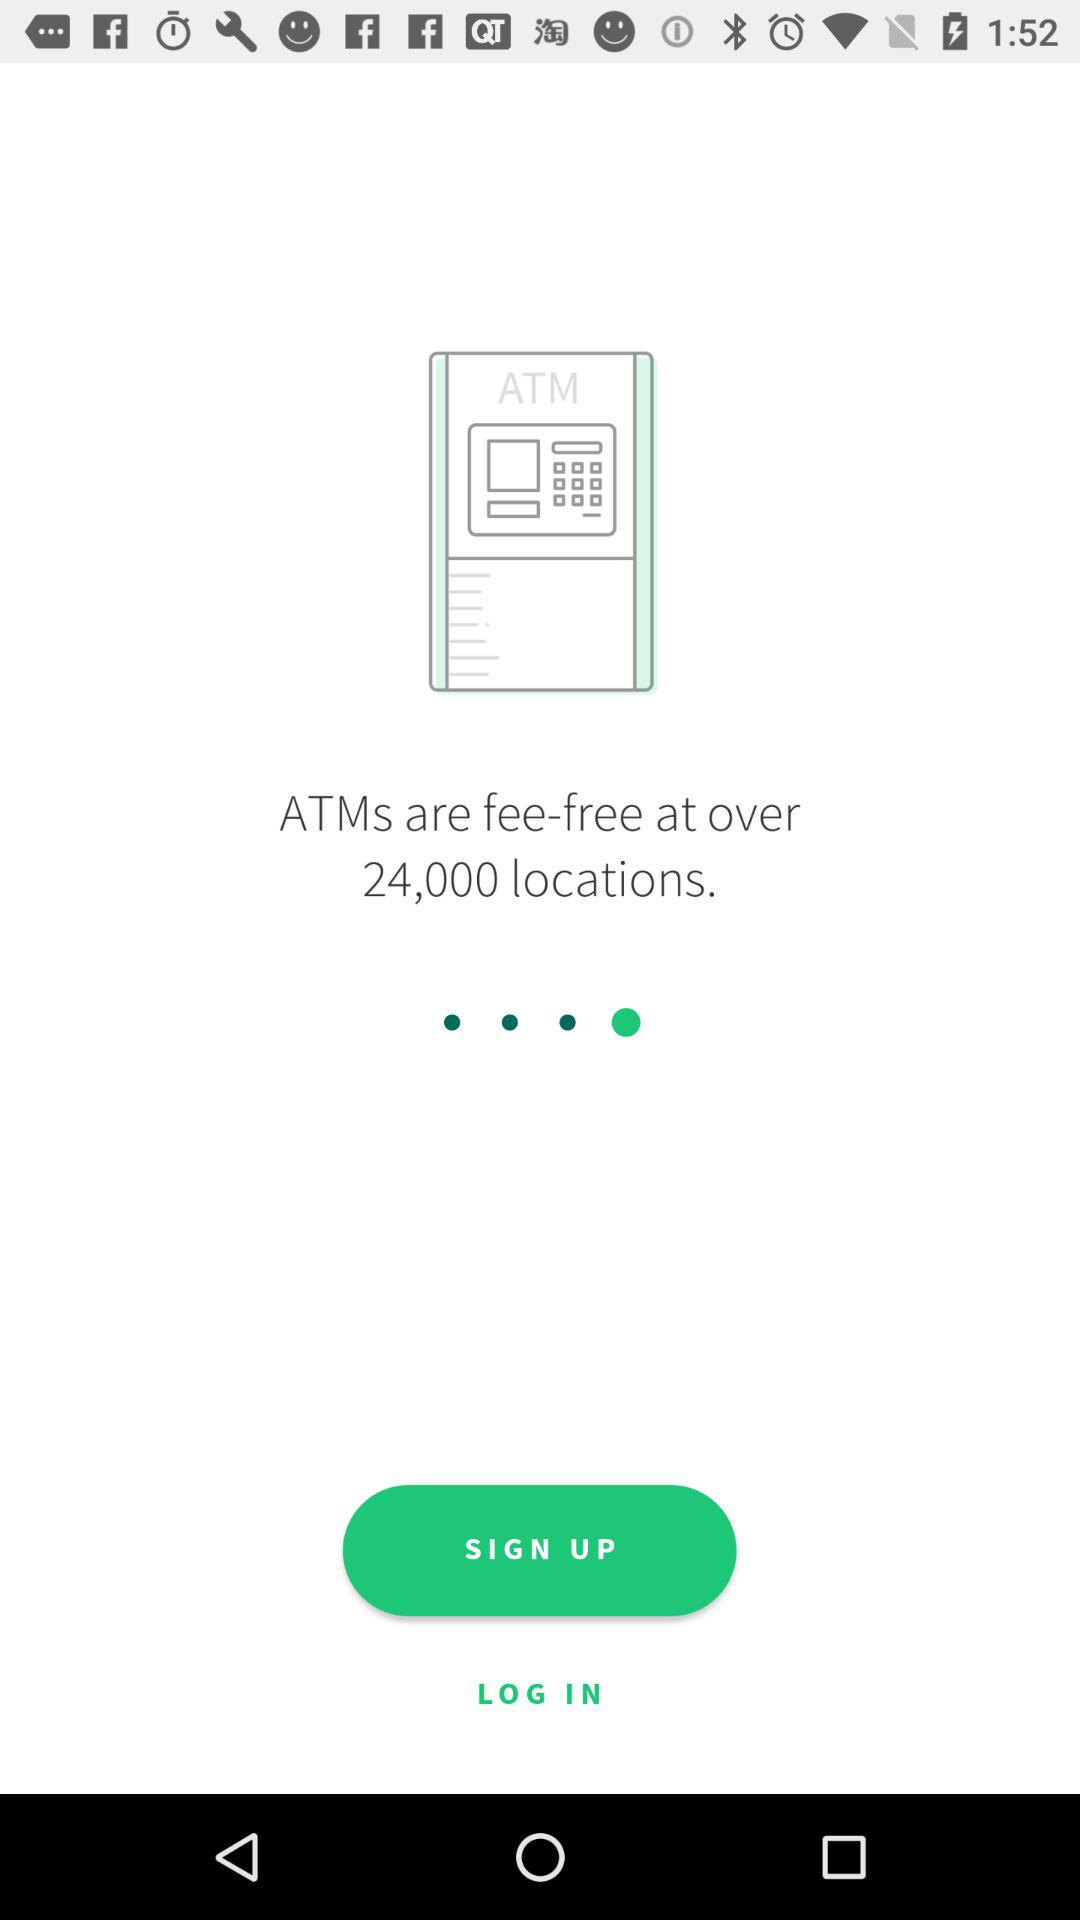At how many locations are ATMs fee-free? ATMs are fee-free at over 24,000 locations. 